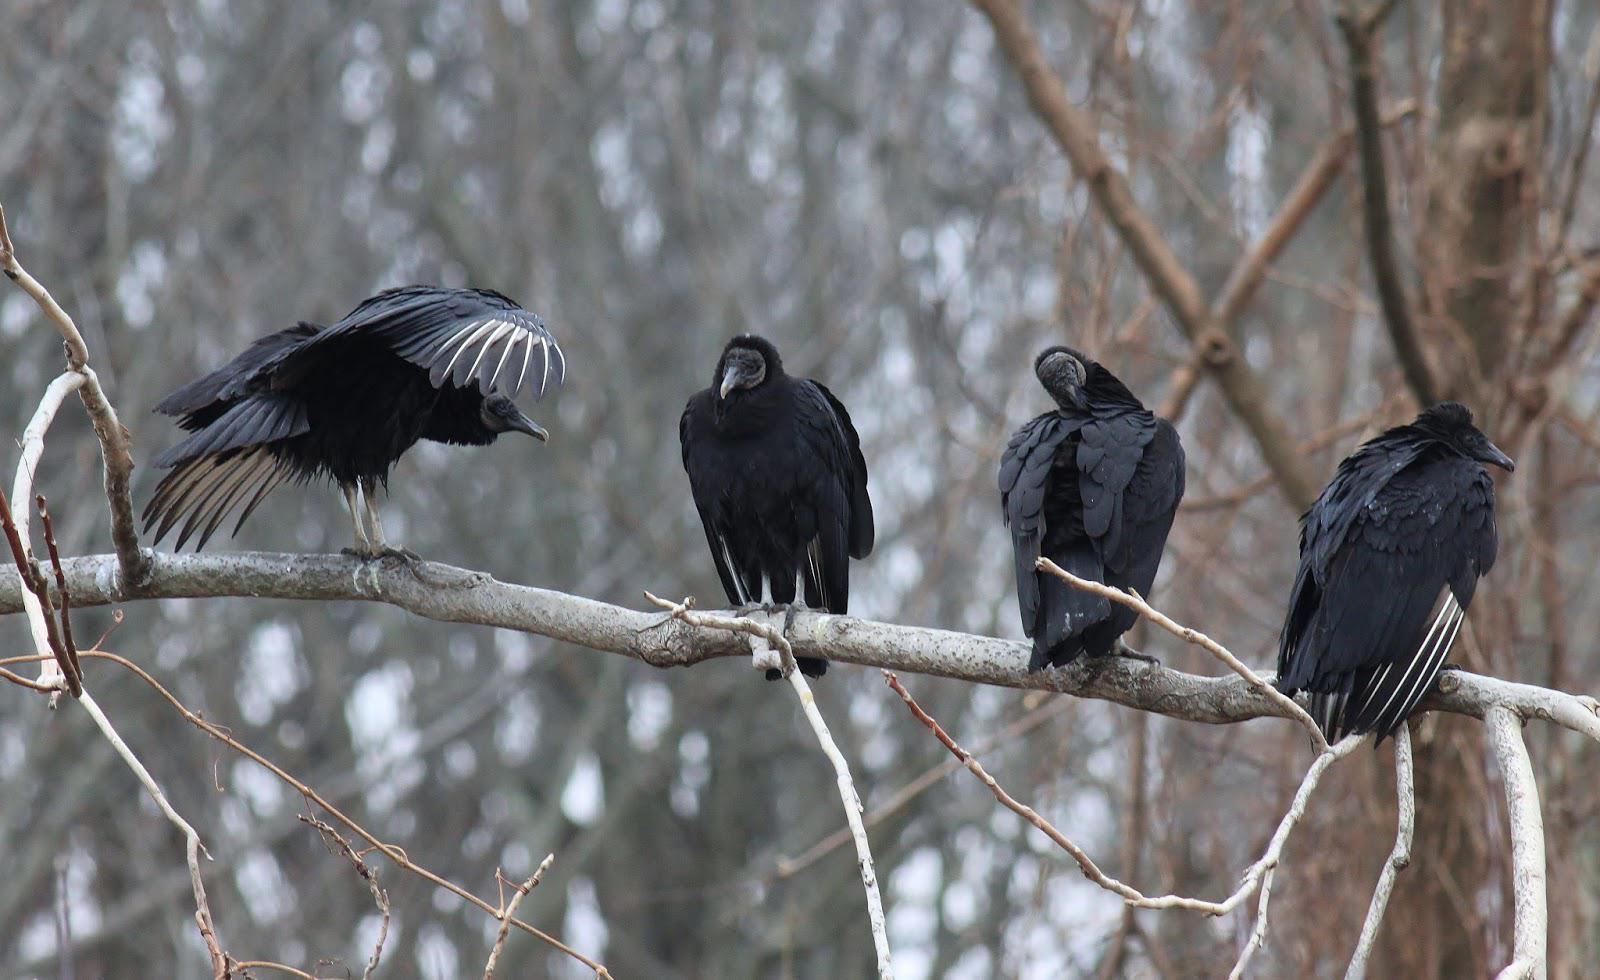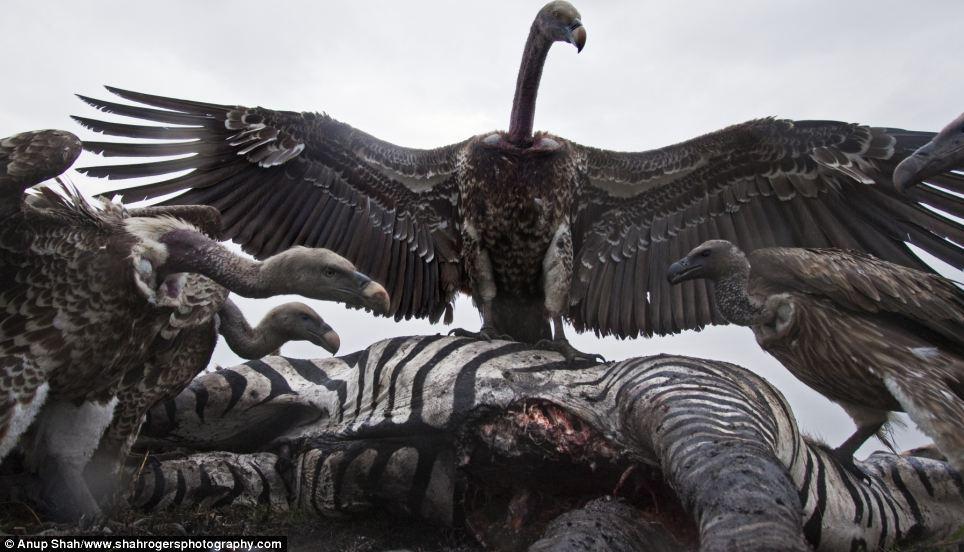The first image is the image on the left, the second image is the image on the right. Analyze the images presented: Is the assertion "A single bird is standing on a stump in the image on the right." valid? Answer yes or no. No. The first image is the image on the left, the second image is the image on the right. For the images shown, is this caption "An image shows vultures next to a zebra carcass." true? Answer yes or no. Yes. 